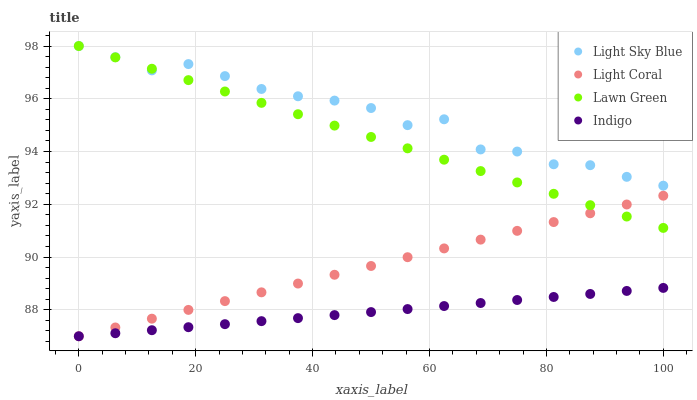Does Indigo have the minimum area under the curve?
Answer yes or no. Yes. Does Light Sky Blue have the maximum area under the curve?
Answer yes or no. Yes. Does Lawn Green have the minimum area under the curve?
Answer yes or no. No. Does Lawn Green have the maximum area under the curve?
Answer yes or no. No. Is Light Coral the smoothest?
Answer yes or no. Yes. Is Light Sky Blue the roughest?
Answer yes or no. Yes. Is Lawn Green the smoothest?
Answer yes or no. No. Is Lawn Green the roughest?
Answer yes or no. No. Does Light Coral have the lowest value?
Answer yes or no. Yes. Does Lawn Green have the lowest value?
Answer yes or no. No. Does Light Sky Blue have the highest value?
Answer yes or no. Yes. Does Indigo have the highest value?
Answer yes or no. No. Is Indigo less than Lawn Green?
Answer yes or no. Yes. Is Light Sky Blue greater than Indigo?
Answer yes or no. Yes. Does Lawn Green intersect Light Sky Blue?
Answer yes or no. Yes. Is Lawn Green less than Light Sky Blue?
Answer yes or no. No. Is Lawn Green greater than Light Sky Blue?
Answer yes or no. No. Does Indigo intersect Lawn Green?
Answer yes or no. No. 